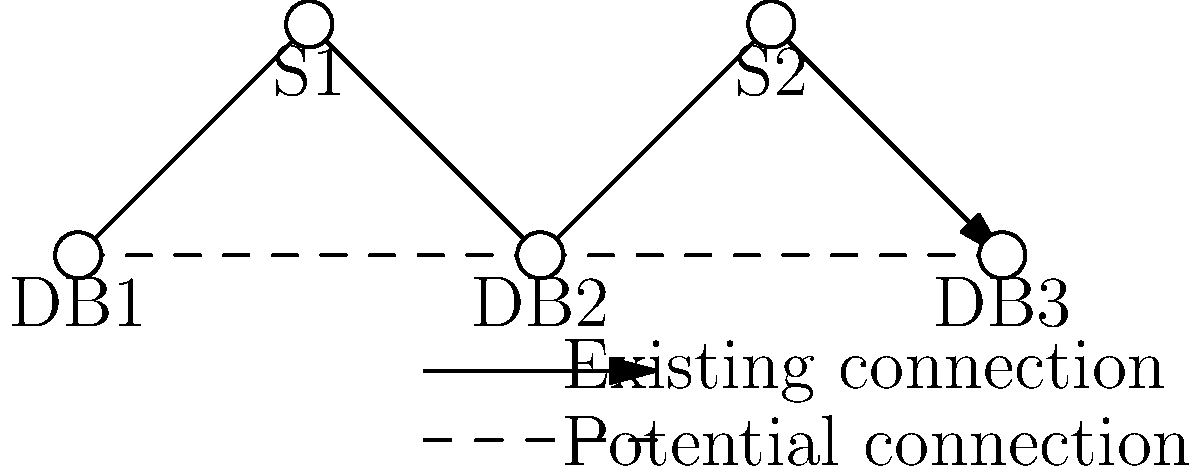Given the network topology shown above, where DB1, DB2, and DB3 are database servers, and S1 and S2 are switch nodes, which potential connection should be implemented to minimize the maximum number of hops between any two database servers? To optimize the network topology for database server communication, we need to analyze the current and potential connections:

1. Current topology:
   - DB1 to DB2: 2 hops (DB1 -> S1 -> DB2)
   - DB2 to DB3: 2 hops (DB2 -> S2 -> DB3)
   - DB1 to DB3: 4 hops (DB1 -> S1 -> DB2 -> S2 -> DB3)

2. Potential connections:
   a. DB1 to DB2 (direct)
   b. DB2 to DB3 (direct)

3. Analysis of potential connections:
   a. If we implement DB1 to DB2:
      - DB1 to DB2: 1 hop
      - DB2 to DB3: 2 hops
      - DB1 to DB3: 3 hops (DB1 -> DB2 -> S2 -> DB3)
      Maximum hops: 3

   b. If we implement DB2 to DB3:
      - DB1 to DB2: 2 hops
      - DB2 to DB3: 1 hop
      - DB1 to DB3: 3 hops (DB1 -> S1 -> DB2 -> DB3)
      Maximum hops: 3

4. Conclusion:
   Both potential connections reduce the maximum number of hops from 4 to 3. However, implementing the DB2 to DB3 connection provides a more balanced distribution of traffic and reduces the load on switch nodes.
Answer: DB2 to DB3 